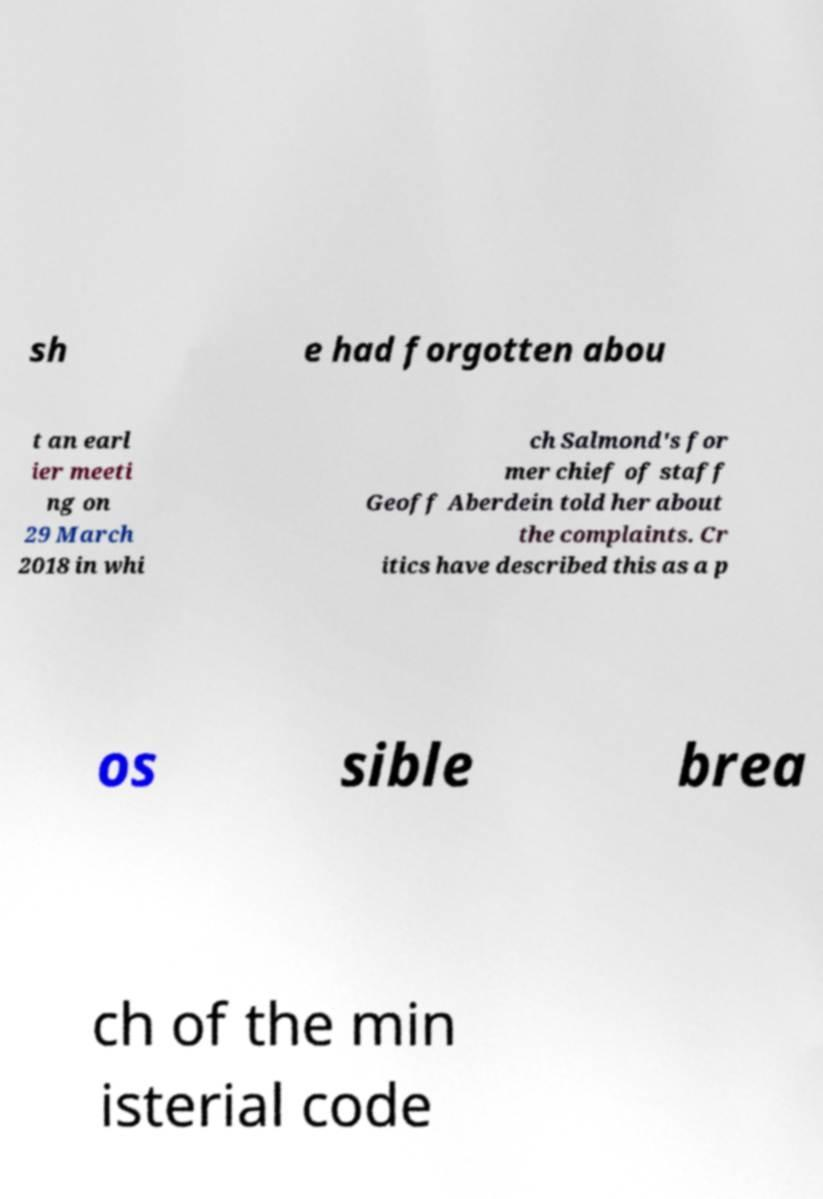There's text embedded in this image that I need extracted. Can you transcribe it verbatim? sh e had forgotten abou t an earl ier meeti ng on 29 March 2018 in whi ch Salmond's for mer chief of staff Geoff Aberdein told her about the complaints. Cr itics have described this as a p os sible brea ch of the min isterial code 